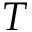Convert formula to latex. <formula><loc_0><loc_0><loc_500><loc_500>T</formula> 